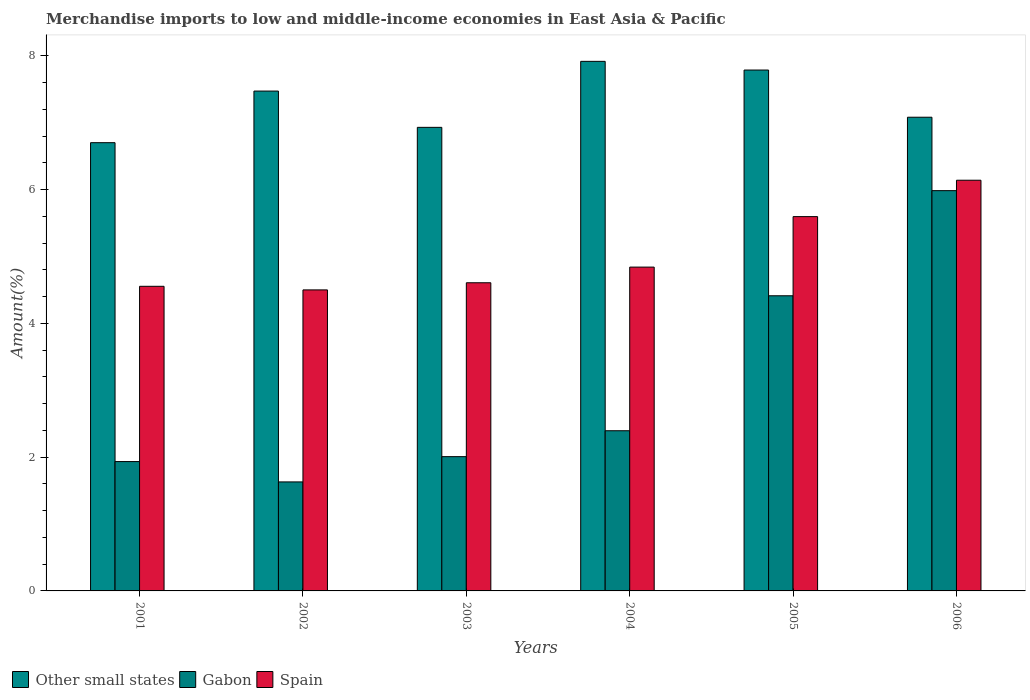How many different coloured bars are there?
Your answer should be compact. 3. How many groups of bars are there?
Offer a terse response. 6. How many bars are there on the 5th tick from the left?
Offer a terse response. 3. What is the percentage of amount earned from merchandise imports in Spain in 2003?
Your answer should be compact. 4.61. Across all years, what is the maximum percentage of amount earned from merchandise imports in Spain?
Make the answer very short. 6.14. Across all years, what is the minimum percentage of amount earned from merchandise imports in Gabon?
Ensure brevity in your answer.  1.63. In which year was the percentage of amount earned from merchandise imports in Gabon minimum?
Offer a very short reply. 2002. What is the total percentage of amount earned from merchandise imports in Spain in the graph?
Your answer should be compact. 30.24. What is the difference between the percentage of amount earned from merchandise imports in Other small states in 2005 and that in 2006?
Your answer should be compact. 0.71. What is the difference between the percentage of amount earned from merchandise imports in Gabon in 2005 and the percentage of amount earned from merchandise imports in Other small states in 2001?
Offer a terse response. -2.29. What is the average percentage of amount earned from merchandise imports in Spain per year?
Provide a succinct answer. 5.04. In the year 2003, what is the difference between the percentage of amount earned from merchandise imports in Other small states and percentage of amount earned from merchandise imports in Spain?
Offer a terse response. 2.32. In how many years, is the percentage of amount earned from merchandise imports in Other small states greater than 4.4 %?
Ensure brevity in your answer.  6. What is the ratio of the percentage of amount earned from merchandise imports in Spain in 2002 to that in 2005?
Your answer should be compact. 0.8. What is the difference between the highest and the second highest percentage of amount earned from merchandise imports in Gabon?
Your answer should be very brief. 1.57. What is the difference between the highest and the lowest percentage of amount earned from merchandise imports in Spain?
Your answer should be compact. 1.64. In how many years, is the percentage of amount earned from merchandise imports in Gabon greater than the average percentage of amount earned from merchandise imports in Gabon taken over all years?
Offer a very short reply. 2. Is the sum of the percentage of amount earned from merchandise imports in Other small states in 2001 and 2004 greater than the maximum percentage of amount earned from merchandise imports in Gabon across all years?
Keep it short and to the point. Yes. What does the 2nd bar from the left in 2005 represents?
Provide a short and direct response. Gabon. What does the 2nd bar from the right in 2005 represents?
Keep it short and to the point. Gabon. Is it the case that in every year, the sum of the percentage of amount earned from merchandise imports in Gabon and percentage of amount earned from merchandise imports in Other small states is greater than the percentage of amount earned from merchandise imports in Spain?
Make the answer very short. Yes. Are all the bars in the graph horizontal?
Provide a short and direct response. No. What is the difference between two consecutive major ticks on the Y-axis?
Offer a very short reply. 2. Are the values on the major ticks of Y-axis written in scientific E-notation?
Your answer should be very brief. No. Does the graph contain grids?
Your answer should be compact. No. Where does the legend appear in the graph?
Make the answer very short. Bottom left. What is the title of the graph?
Keep it short and to the point. Merchandise imports to low and middle-income economies in East Asia & Pacific. What is the label or title of the X-axis?
Ensure brevity in your answer.  Years. What is the label or title of the Y-axis?
Your answer should be compact. Amount(%). What is the Amount(%) of Other small states in 2001?
Provide a succinct answer. 6.7. What is the Amount(%) of Gabon in 2001?
Your response must be concise. 1.93. What is the Amount(%) in Spain in 2001?
Your response must be concise. 4.55. What is the Amount(%) of Other small states in 2002?
Your response must be concise. 7.47. What is the Amount(%) in Gabon in 2002?
Provide a succinct answer. 1.63. What is the Amount(%) of Spain in 2002?
Your answer should be very brief. 4.5. What is the Amount(%) in Other small states in 2003?
Your response must be concise. 6.93. What is the Amount(%) in Gabon in 2003?
Offer a terse response. 2.01. What is the Amount(%) in Spain in 2003?
Give a very brief answer. 4.61. What is the Amount(%) of Other small states in 2004?
Your answer should be very brief. 7.92. What is the Amount(%) in Gabon in 2004?
Provide a short and direct response. 2.39. What is the Amount(%) in Spain in 2004?
Provide a short and direct response. 4.84. What is the Amount(%) of Other small states in 2005?
Your answer should be very brief. 7.79. What is the Amount(%) of Gabon in 2005?
Your response must be concise. 4.41. What is the Amount(%) in Spain in 2005?
Give a very brief answer. 5.6. What is the Amount(%) of Other small states in 2006?
Provide a succinct answer. 7.08. What is the Amount(%) in Gabon in 2006?
Ensure brevity in your answer.  5.99. What is the Amount(%) in Spain in 2006?
Your answer should be compact. 6.14. Across all years, what is the maximum Amount(%) in Other small states?
Your answer should be compact. 7.92. Across all years, what is the maximum Amount(%) in Gabon?
Make the answer very short. 5.99. Across all years, what is the maximum Amount(%) of Spain?
Make the answer very short. 6.14. Across all years, what is the minimum Amount(%) in Other small states?
Ensure brevity in your answer.  6.7. Across all years, what is the minimum Amount(%) of Gabon?
Your answer should be very brief. 1.63. Across all years, what is the minimum Amount(%) in Spain?
Ensure brevity in your answer.  4.5. What is the total Amount(%) in Other small states in the graph?
Your answer should be very brief. 43.9. What is the total Amount(%) of Gabon in the graph?
Provide a succinct answer. 18.36. What is the total Amount(%) in Spain in the graph?
Give a very brief answer. 30.24. What is the difference between the Amount(%) in Other small states in 2001 and that in 2002?
Your answer should be compact. -0.77. What is the difference between the Amount(%) in Gabon in 2001 and that in 2002?
Make the answer very short. 0.3. What is the difference between the Amount(%) of Spain in 2001 and that in 2002?
Your answer should be compact. 0.05. What is the difference between the Amount(%) of Other small states in 2001 and that in 2003?
Offer a very short reply. -0.23. What is the difference between the Amount(%) of Gabon in 2001 and that in 2003?
Keep it short and to the point. -0.07. What is the difference between the Amount(%) in Spain in 2001 and that in 2003?
Provide a short and direct response. -0.05. What is the difference between the Amount(%) of Other small states in 2001 and that in 2004?
Keep it short and to the point. -1.22. What is the difference between the Amount(%) in Gabon in 2001 and that in 2004?
Offer a very short reply. -0.46. What is the difference between the Amount(%) of Spain in 2001 and that in 2004?
Provide a short and direct response. -0.29. What is the difference between the Amount(%) in Other small states in 2001 and that in 2005?
Your answer should be compact. -1.09. What is the difference between the Amount(%) of Gabon in 2001 and that in 2005?
Provide a succinct answer. -2.48. What is the difference between the Amount(%) of Spain in 2001 and that in 2005?
Give a very brief answer. -1.04. What is the difference between the Amount(%) of Other small states in 2001 and that in 2006?
Keep it short and to the point. -0.38. What is the difference between the Amount(%) in Gabon in 2001 and that in 2006?
Make the answer very short. -4.05. What is the difference between the Amount(%) in Spain in 2001 and that in 2006?
Provide a succinct answer. -1.59. What is the difference between the Amount(%) of Other small states in 2002 and that in 2003?
Provide a short and direct response. 0.54. What is the difference between the Amount(%) of Gabon in 2002 and that in 2003?
Make the answer very short. -0.38. What is the difference between the Amount(%) of Spain in 2002 and that in 2003?
Your answer should be very brief. -0.11. What is the difference between the Amount(%) in Other small states in 2002 and that in 2004?
Provide a succinct answer. -0.44. What is the difference between the Amount(%) of Gabon in 2002 and that in 2004?
Your answer should be very brief. -0.77. What is the difference between the Amount(%) in Spain in 2002 and that in 2004?
Your answer should be very brief. -0.34. What is the difference between the Amount(%) in Other small states in 2002 and that in 2005?
Offer a very short reply. -0.31. What is the difference between the Amount(%) in Gabon in 2002 and that in 2005?
Provide a short and direct response. -2.78. What is the difference between the Amount(%) of Spain in 2002 and that in 2005?
Provide a succinct answer. -1.1. What is the difference between the Amount(%) of Other small states in 2002 and that in 2006?
Your answer should be compact. 0.39. What is the difference between the Amount(%) of Gabon in 2002 and that in 2006?
Give a very brief answer. -4.36. What is the difference between the Amount(%) in Spain in 2002 and that in 2006?
Ensure brevity in your answer.  -1.64. What is the difference between the Amount(%) in Other small states in 2003 and that in 2004?
Make the answer very short. -0.99. What is the difference between the Amount(%) of Gabon in 2003 and that in 2004?
Give a very brief answer. -0.39. What is the difference between the Amount(%) of Spain in 2003 and that in 2004?
Provide a short and direct response. -0.23. What is the difference between the Amount(%) of Other small states in 2003 and that in 2005?
Your response must be concise. -0.86. What is the difference between the Amount(%) in Gabon in 2003 and that in 2005?
Offer a very short reply. -2.41. What is the difference between the Amount(%) in Spain in 2003 and that in 2005?
Provide a succinct answer. -0.99. What is the difference between the Amount(%) of Other small states in 2003 and that in 2006?
Give a very brief answer. -0.15. What is the difference between the Amount(%) in Gabon in 2003 and that in 2006?
Your response must be concise. -3.98. What is the difference between the Amount(%) in Spain in 2003 and that in 2006?
Offer a terse response. -1.53. What is the difference between the Amount(%) in Other small states in 2004 and that in 2005?
Give a very brief answer. 0.13. What is the difference between the Amount(%) in Gabon in 2004 and that in 2005?
Offer a very short reply. -2.02. What is the difference between the Amount(%) in Spain in 2004 and that in 2005?
Your answer should be very brief. -0.75. What is the difference between the Amount(%) of Other small states in 2004 and that in 2006?
Your answer should be very brief. 0.84. What is the difference between the Amount(%) in Gabon in 2004 and that in 2006?
Offer a terse response. -3.59. What is the difference between the Amount(%) of Spain in 2004 and that in 2006?
Provide a short and direct response. -1.3. What is the difference between the Amount(%) of Other small states in 2005 and that in 2006?
Provide a succinct answer. 0.71. What is the difference between the Amount(%) of Gabon in 2005 and that in 2006?
Provide a short and direct response. -1.57. What is the difference between the Amount(%) of Spain in 2005 and that in 2006?
Your answer should be compact. -0.54. What is the difference between the Amount(%) of Other small states in 2001 and the Amount(%) of Gabon in 2002?
Provide a short and direct response. 5.07. What is the difference between the Amount(%) of Other small states in 2001 and the Amount(%) of Spain in 2002?
Your answer should be compact. 2.2. What is the difference between the Amount(%) in Gabon in 2001 and the Amount(%) in Spain in 2002?
Your answer should be very brief. -2.57. What is the difference between the Amount(%) in Other small states in 2001 and the Amount(%) in Gabon in 2003?
Ensure brevity in your answer.  4.69. What is the difference between the Amount(%) in Other small states in 2001 and the Amount(%) in Spain in 2003?
Your response must be concise. 2.09. What is the difference between the Amount(%) of Gabon in 2001 and the Amount(%) of Spain in 2003?
Give a very brief answer. -2.67. What is the difference between the Amount(%) of Other small states in 2001 and the Amount(%) of Gabon in 2004?
Make the answer very short. 4.31. What is the difference between the Amount(%) of Other small states in 2001 and the Amount(%) of Spain in 2004?
Make the answer very short. 1.86. What is the difference between the Amount(%) of Gabon in 2001 and the Amount(%) of Spain in 2004?
Your answer should be compact. -2.91. What is the difference between the Amount(%) in Other small states in 2001 and the Amount(%) in Gabon in 2005?
Provide a short and direct response. 2.29. What is the difference between the Amount(%) of Other small states in 2001 and the Amount(%) of Spain in 2005?
Your answer should be compact. 1.11. What is the difference between the Amount(%) in Gabon in 2001 and the Amount(%) in Spain in 2005?
Provide a succinct answer. -3.66. What is the difference between the Amount(%) of Other small states in 2001 and the Amount(%) of Gabon in 2006?
Provide a short and direct response. 0.72. What is the difference between the Amount(%) in Other small states in 2001 and the Amount(%) in Spain in 2006?
Provide a short and direct response. 0.56. What is the difference between the Amount(%) of Gabon in 2001 and the Amount(%) of Spain in 2006?
Make the answer very short. -4.21. What is the difference between the Amount(%) of Other small states in 2002 and the Amount(%) of Gabon in 2003?
Keep it short and to the point. 5.47. What is the difference between the Amount(%) of Other small states in 2002 and the Amount(%) of Spain in 2003?
Ensure brevity in your answer.  2.87. What is the difference between the Amount(%) of Gabon in 2002 and the Amount(%) of Spain in 2003?
Your response must be concise. -2.98. What is the difference between the Amount(%) in Other small states in 2002 and the Amount(%) in Gabon in 2004?
Keep it short and to the point. 5.08. What is the difference between the Amount(%) in Other small states in 2002 and the Amount(%) in Spain in 2004?
Your answer should be very brief. 2.63. What is the difference between the Amount(%) of Gabon in 2002 and the Amount(%) of Spain in 2004?
Offer a very short reply. -3.21. What is the difference between the Amount(%) in Other small states in 2002 and the Amount(%) in Gabon in 2005?
Offer a very short reply. 3.06. What is the difference between the Amount(%) in Other small states in 2002 and the Amount(%) in Spain in 2005?
Keep it short and to the point. 1.88. What is the difference between the Amount(%) in Gabon in 2002 and the Amount(%) in Spain in 2005?
Provide a succinct answer. -3.97. What is the difference between the Amount(%) in Other small states in 2002 and the Amount(%) in Gabon in 2006?
Your answer should be compact. 1.49. What is the difference between the Amount(%) of Other small states in 2002 and the Amount(%) of Spain in 2006?
Keep it short and to the point. 1.33. What is the difference between the Amount(%) in Gabon in 2002 and the Amount(%) in Spain in 2006?
Offer a very short reply. -4.51. What is the difference between the Amount(%) of Other small states in 2003 and the Amount(%) of Gabon in 2004?
Provide a short and direct response. 4.54. What is the difference between the Amount(%) of Other small states in 2003 and the Amount(%) of Spain in 2004?
Keep it short and to the point. 2.09. What is the difference between the Amount(%) in Gabon in 2003 and the Amount(%) in Spain in 2004?
Offer a terse response. -2.83. What is the difference between the Amount(%) in Other small states in 2003 and the Amount(%) in Gabon in 2005?
Your answer should be very brief. 2.52. What is the difference between the Amount(%) in Other small states in 2003 and the Amount(%) in Spain in 2005?
Provide a short and direct response. 1.33. What is the difference between the Amount(%) of Gabon in 2003 and the Amount(%) of Spain in 2005?
Your answer should be very brief. -3.59. What is the difference between the Amount(%) in Other small states in 2003 and the Amount(%) in Gabon in 2006?
Your response must be concise. 0.95. What is the difference between the Amount(%) in Other small states in 2003 and the Amount(%) in Spain in 2006?
Provide a short and direct response. 0.79. What is the difference between the Amount(%) of Gabon in 2003 and the Amount(%) of Spain in 2006?
Make the answer very short. -4.13. What is the difference between the Amount(%) of Other small states in 2004 and the Amount(%) of Gabon in 2005?
Your answer should be compact. 3.51. What is the difference between the Amount(%) of Other small states in 2004 and the Amount(%) of Spain in 2005?
Your answer should be very brief. 2.32. What is the difference between the Amount(%) of Gabon in 2004 and the Amount(%) of Spain in 2005?
Your response must be concise. -3.2. What is the difference between the Amount(%) of Other small states in 2004 and the Amount(%) of Gabon in 2006?
Offer a terse response. 1.93. What is the difference between the Amount(%) of Other small states in 2004 and the Amount(%) of Spain in 2006?
Give a very brief answer. 1.78. What is the difference between the Amount(%) in Gabon in 2004 and the Amount(%) in Spain in 2006?
Provide a short and direct response. -3.75. What is the difference between the Amount(%) in Other small states in 2005 and the Amount(%) in Gabon in 2006?
Make the answer very short. 1.8. What is the difference between the Amount(%) in Other small states in 2005 and the Amount(%) in Spain in 2006?
Your response must be concise. 1.65. What is the difference between the Amount(%) of Gabon in 2005 and the Amount(%) of Spain in 2006?
Your response must be concise. -1.73. What is the average Amount(%) of Other small states per year?
Your response must be concise. 7.32. What is the average Amount(%) of Gabon per year?
Ensure brevity in your answer.  3.06. What is the average Amount(%) in Spain per year?
Make the answer very short. 5.04. In the year 2001, what is the difference between the Amount(%) in Other small states and Amount(%) in Gabon?
Ensure brevity in your answer.  4.77. In the year 2001, what is the difference between the Amount(%) in Other small states and Amount(%) in Spain?
Make the answer very short. 2.15. In the year 2001, what is the difference between the Amount(%) in Gabon and Amount(%) in Spain?
Offer a very short reply. -2.62. In the year 2002, what is the difference between the Amount(%) of Other small states and Amount(%) of Gabon?
Ensure brevity in your answer.  5.84. In the year 2002, what is the difference between the Amount(%) in Other small states and Amount(%) in Spain?
Give a very brief answer. 2.97. In the year 2002, what is the difference between the Amount(%) of Gabon and Amount(%) of Spain?
Provide a short and direct response. -2.87. In the year 2003, what is the difference between the Amount(%) in Other small states and Amount(%) in Gabon?
Give a very brief answer. 4.92. In the year 2003, what is the difference between the Amount(%) of Other small states and Amount(%) of Spain?
Provide a succinct answer. 2.32. In the year 2003, what is the difference between the Amount(%) of Gabon and Amount(%) of Spain?
Provide a short and direct response. -2.6. In the year 2004, what is the difference between the Amount(%) in Other small states and Amount(%) in Gabon?
Ensure brevity in your answer.  5.52. In the year 2004, what is the difference between the Amount(%) of Other small states and Amount(%) of Spain?
Provide a succinct answer. 3.08. In the year 2004, what is the difference between the Amount(%) in Gabon and Amount(%) in Spain?
Keep it short and to the point. -2.45. In the year 2005, what is the difference between the Amount(%) in Other small states and Amount(%) in Gabon?
Your response must be concise. 3.38. In the year 2005, what is the difference between the Amount(%) of Other small states and Amount(%) of Spain?
Provide a succinct answer. 2.19. In the year 2005, what is the difference between the Amount(%) of Gabon and Amount(%) of Spain?
Keep it short and to the point. -1.18. In the year 2006, what is the difference between the Amount(%) of Other small states and Amount(%) of Gabon?
Ensure brevity in your answer.  1.1. In the year 2006, what is the difference between the Amount(%) of Other small states and Amount(%) of Spain?
Offer a very short reply. 0.94. In the year 2006, what is the difference between the Amount(%) of Gabon and Amount(%) of Spain?
Offer a very short reply. -0.16. What is the ratio of the Amount(%) in Other small states in 2001 to that in 2002?
Provide a succinct answer. 0.9. What is the ratio of the Amount(%) of Gabon in 2001 to that in 2002?
Your response must be concise. 1.19. What is the ratio of the Amount(%) of Spain in 2001 to that in 2002?
Your answer should be very brief. 1.01. What is the ratio of the Amount(%) in Other small states in 2001 to that in 2003?
Your response must be concise. 0.97. What is the ratio of the Amount(%) of Gabon in 2001 to that in 2003?
Make the answer very short. 0.96. What is the ratio of the Amount(%) in Other small states in 2001 to that in 2004?
Give a very brief answer. 0.85. What is the ratio of the Amount(%) in Gabon in 2001 to that in 2004?
Your answer should be very brief. 0.81. What is the ratio of the Amount(%) in Spain in 2001 to that in 2004?
Your answer should be very brief. 0.94. What is the ratio of the Amount(%) of Other small states in 2001 to that in 2005?
Give a very brief answer. 0.86. What is the ratio of the Amount(%) in Gabon in 2001 to that in 2005?
Offer a terse response. 0.44. What is the ratio of the Amount(%) of Spain in 2001 to that in 2005?
Offer a very short reply. 0.81. What is the ratio of the Amount(%) of Other small states in 2001 to that in 2006?
Make the answer very short. 0.95. What is the ratio of the Amount(%) of Gabon in 2001 to that in 2006?
Your answer should be compact. 0.32. What is the ratio of the Amount(%) of Spain in 2001 to that in 2006?
Your answer should be very brief. 0.74. What is the ratio of the Amount(%) of Other small states in 2002 to that in 2003?
Offer a very short reply. 1.08. What is the ratio of the Amount(%) of Gabon in 2002 to that in 2003?
Offer a terse response. 0.81. What is the ratio of the Amount(%) in Spain in 2002 to that in 2003?
Keep it short and to the point. 0.98. What is the ratio of the Amount(%) in Other small states in 2002 to that in 2004?
Make the answer very short. 0.94. What is the ratio of the Amount(%) in Gabon in 2002 to that in 2004?
Your answer should be compact. 0.68. What is the ratio of the Amount(%) of Spain in 2002 to that in 2004?
Offer a terse response. 0.93. What is the ratio of the Amount(%) in Other small states in 2002 to that in 2005?
Offer a very short reply. 0.96. What is the ratio of the Amount(%) in Gabon in 2002 to that in 2005?
Give a very brief answer. 0.37. What is the ratio of the Amount(%) of Spain in 2002 to that in 2005?
Keep it short and to the point. 0.8. What is the ratio of the Amount(%) of Other small states in 2002 to that in 2006?
Your response must be concise. 1.06. What is the ratio of the Amount(%) of Gabon in 2002 to that in 2006?
Provide a short and direct response. 0.27. What is the ratio of the Amount(%) of Spain in 2002 to that in 2006?
Ensure brevity in your answer.  0.73. What is the ratio of the Amount(%) in Other small states in 2003 to that in 2004?
Your response must be concise. 0.88. What is the ratio of the Amount(%) of Gabon in 2003 to that in 2004?
Provide a succinct answer. 0.84. What is the ratio of the Amount(%) in Spain in 2003 to that in 2004?
Keep it short and to the point. 0.95. What is the ratio of the Amount(%) of Other small states in 2003 to that in 2005?
Provide a short and direct response. 0.89. What is the ratio of the Amount(%) in Gabon in 2003 to that in 2005?
Make the answer very short. 0.45. What is the ratio of the Amount(%) in Spain in 2003 to that in 2005?
Offer a very short reply. 0.82. What is the ratio of the Amount(%) in Other small states in 2003 to that in 2006?
Your response must be concise. 0.98. What is the ratio of the Amount(%) in Gabon in 2003 to that in 2006?
Offer a terse response. 0.34. What is the ratio of the Amount(%) in Spain in 2003 to that in 2006?
Offer a terse response. 0.75. What is the ratio of the Amount(%) of Other small states in 2004 to that in 2005?
Offer a terse response. 1.02. What is the ratio of the Amount(%) in Gabon in 2004 to that in 2005?
Provide a succinct answer. 0.54. What is the ratio of the Amount(%) in Spain in 2004 to that in 2005?
Ensure brevity in your answer.  0.87. What is the ratio of the Amount(%) of Other small states in 2004 to that in 2006?
Make the answer very short. 1.12. What is the ratio of the Amount(%) in Gabon in 2004 to that in 2006?
Give a very brief answer. 0.4. What is the ratio of the Amount(%) in Spain in 2004 to that in 2006?
Keep it short and to the point. 0.79. What is the ratio of the Amount(%) of Other small states in 2005 to that in 2006?
Make the answer very short. 1.1. What is the ratio of the Amount(%) of Gabon in 2005 to that in 2006?
Provide a short and direct response. 0.74. What is the ratio of the Amount(%) in Spain in 2005 to that in 2006?
Your answer should be compact. 0.91. What is the difference between the highest and the second highest Amount(%) in Other small states?
Ensure brevity in your answer.  0.13. What is the difference between the highest and the second highest Amount(%) in Gabon?
Give a very brief answer. 1.57. What is the difference between the highest and the second highest Amount(%) in Spain?
Your response must be concise. 0.54. What is the difference between the highest and the lowest Amount(%) in Other small states?
Keep it short and to the point. 1.22. What is the difference between the highest and the lowest Amount(%) in Gabon?
Ensure brevity in your answer.  4.36. What is the difference between the highest and the lowest Amount(%) of Spain?
Provide a short and direct response. 1.64. 